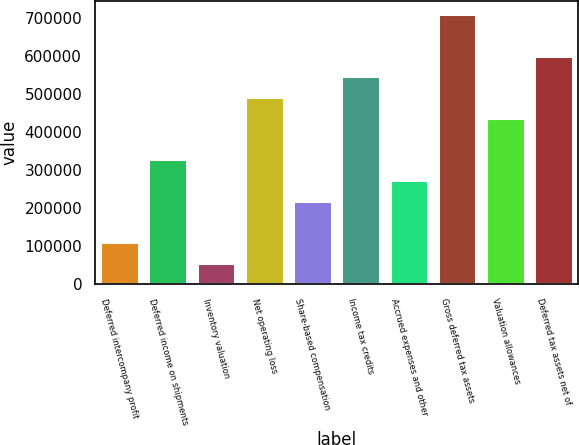Convert chart to OTSL. <chart><loc_0><loc_0><loc_500><loc_500><bar_chart><fcel>Deferred intercompany profit<fcel>Deferred income on shipments<fcel>Inventory valuation<fcel>Net operating loss<fcel>Share-based compensation<fcel>Income tax credits<fcel>Accrued expenses and other<fcel>Gross deferred tax assets<fcel>Valuation allowances<fcel>Deferred tax assets net of<nl><fcel>110758<fcel>328389<fcel>56349.8<fcel>491612<fcel>219573<fcel>546020<fcel>273981<fcel>709243<fcel>437204<fcel>600428<nl></chart> 